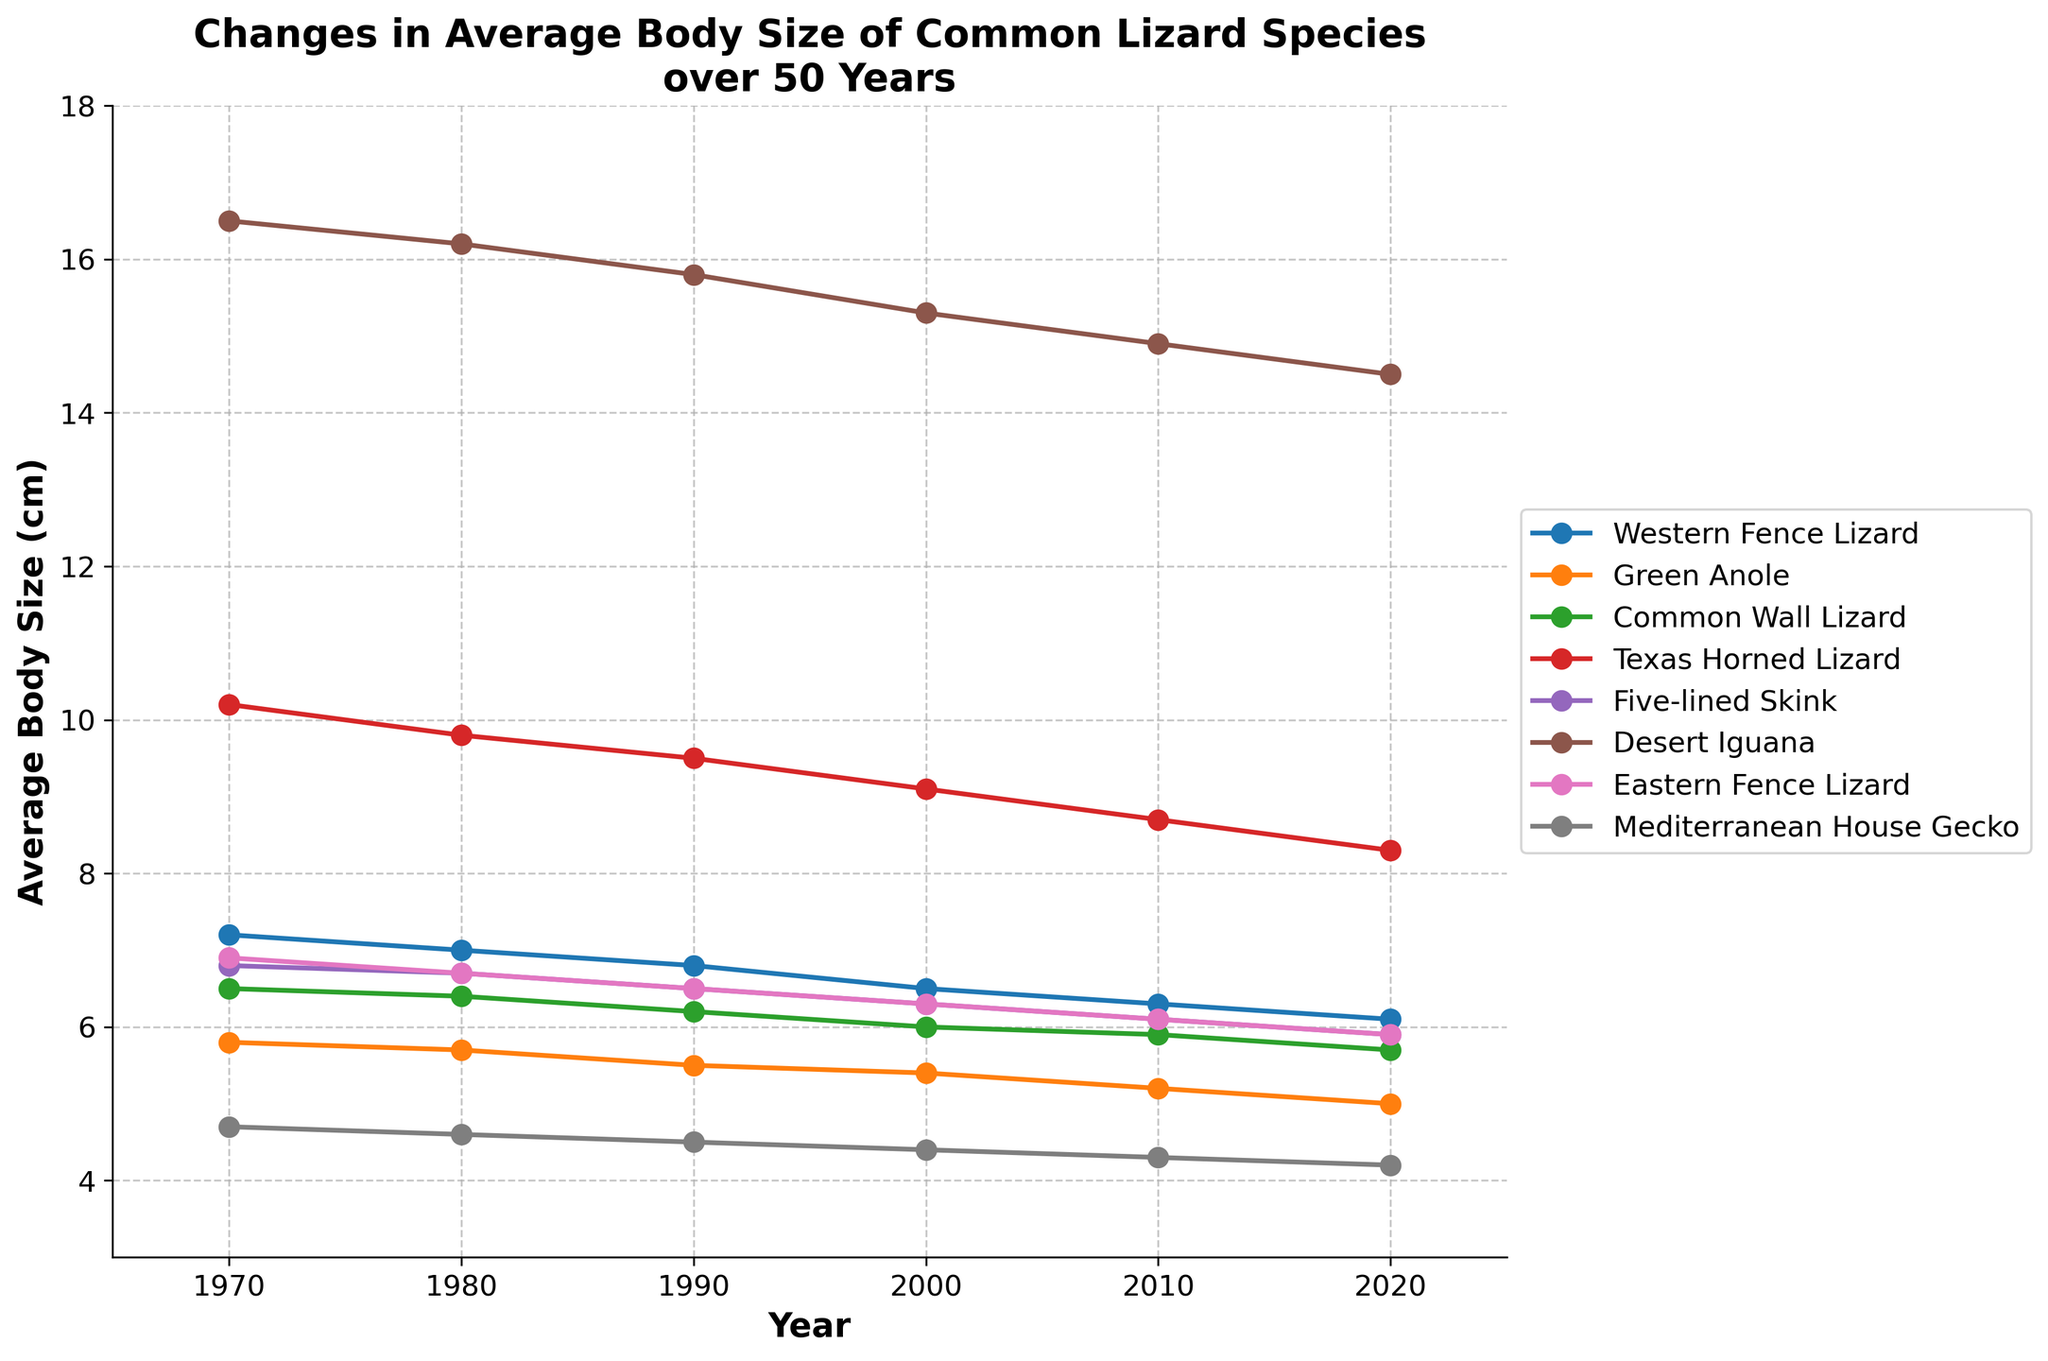What is the overall trend of the average body size of the Western Fence Lizard over 50 years? To observe the overall trend, look at the data points for the Western Fence Lizard across the years from 1970 to 2020. The graph displays a steady decline in average body size.
Answer: Decline Which species shows the greatest decrease in average body size from 1970 to 2020? Calculate the difference between the average body size in 1970 and 2020 for each species. The Texas Horned Lizard shows the greatest decrease (10.2 - 8.3 = 1.9 cm).
Answer: Texas Horned Lizard How does the body size of the Mediterranean House Gecko in 1970 compare to its size in 2020? Locate the data points for the Mediterranean House Gecko in 1970 and 2020. The average body size decreases from 4.7 cm to 4.2 cm.
Answer: Decreased Which two species have nearly parallel trends in their body sizes over the years? Look for species whose lines run in a similar pattern throughout the chart. The Western Fence Lizard and the Eastern Fence Lizard exhibit nearly parallel trends.
Answer: Western Fence Lizard and Eastern Fence Lizard What is the average body size of the Desert Iguana in the middle year 2000? Identify the data point for the Desert Iguana in the year 2000. The average body size is 15.3 cm.
Answer: 15.3 cm By how much did the average body size of the Green Anole decrease from 1980 to 2000? Subtract the value in 2000 from the value in 1980 for the Green Anole. The decrease is 5.7 - 5.4 = 0.3 cm.
Answer: 0.3 cm Which species has the smallest average body size in any given year, and in what year is this observed? Scan the data points to find the smallest average body size. The Mediterranean House Gecko has the smallest size at 4.2 cm in 2020.
Answer: Mediterranean House Gecko in 2020 What is the total decrease in body size for the Common Wall Lizard from 1970 to 2000? Calculate the difference in body size from 1970 to 2000 for the Common Wall Lizard. 6.5 - 6.0 = 0.5 cm.
Answer: 0.5 cm Calculate the average body size for the Western Fence Lizard over the 50 years. Sum the body sizes for each year (7.2 + 7.0 + 6.8 + 6.5 + 6.3 + 6.1) and divide by 6 (number of years). The average is (7.2 + 7.0 + 6.8 + 6.5 + 6.3 + 6.1) / 6 = 6.65 cm.
Answer: 6.65 cm 